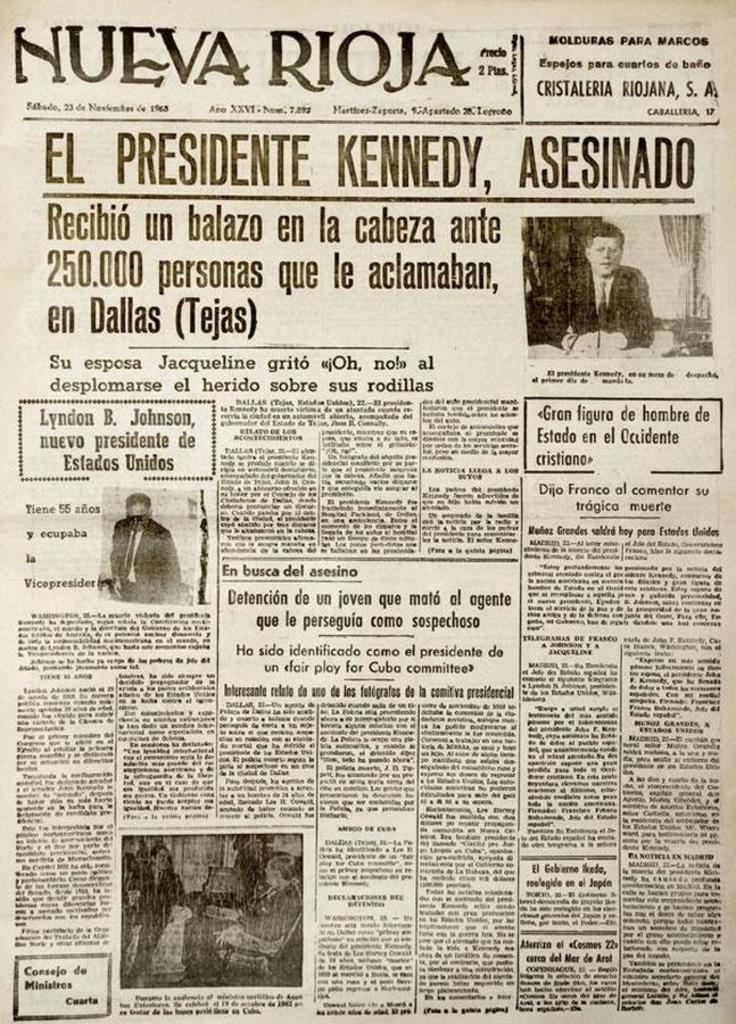What is present in the image? There is a newspaper in the image. What types of content can be found in the newspaper? The newspaper contains images, words, and numbers. What is the opinion of the mass on the business in the image? There is no indication of the mass's opinion on the business in the image, as the newspaper only contains images, words, and numbers. 